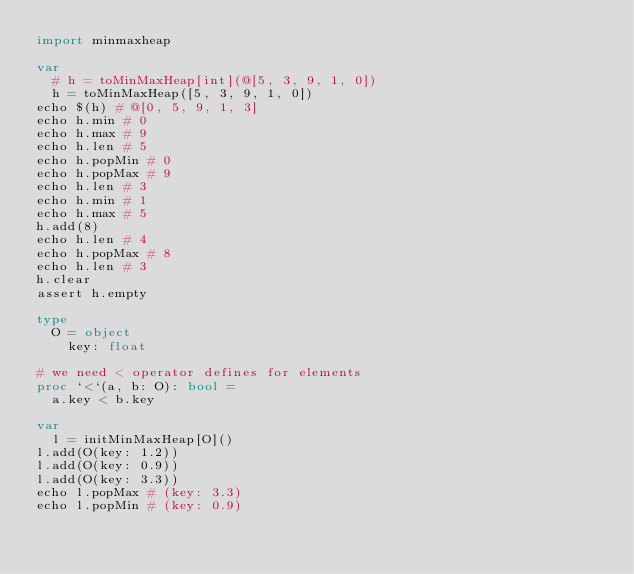<code> <loc_0><loc_0><loc_500><loc_500><_Nim_>import minmaxheap

var
  # h = toMinMaxHeap[int](@[5, 3, 9, 1, 0])
  h = toMinMaxHeap([5, 3, 9, 1, 0])
echo $(h) # @[0, 5, 9, 1, 3]
echo h.min # 0
echo h.max # 9
echo h.len # 5
echo h.popMin # 0
echo h.popMax # 9
echo h.len # 3
echo h.min # 1
echo h.max # 5
h.add(8)
echo h.len # 4
echo h.popMax # 8
echo h.len # 3
h.clear
assert h.empty

type
  O = object
    key: float

# we need < operator defines for elements
proc `<`(a, b: O): bool =
  a.key < b.key

var
  l = initMinMaxHeap[O]()
l.add(O(key: 1.2))
l.add(O(key: 0.9))
l.add(O(key: 3.3))
echo l.popMax # (key: 3.3)
echo l.popMin # (key: 0.9)
</code> 